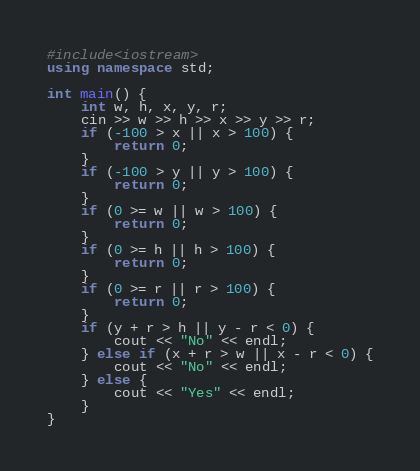Convert code to text. <code><loc_0><loc_0><loc_500><loc_500><_C++_>#include<iostream>
using namespace std;

int main() {
    int w, h, x, y, r;
    cin >> w >> h >> x >> y >> r;
    if (-100 > x || x > 100) {
        return 0;
    }
    if (-100 > y || y > 100) {
        return 0;
    }
    if (0 >= w || w > 100) {
        return 0;
    }
    if (0 >= h || h > 100) {
        return 0;
    }
    if (0 >= r || r > 100) {
        return 0;
    }
    if (y + r > h || y - r < 0) {
        cout << "No" << endl;
    } else if (x + r > w || x - r < 0) {
        cout << "No" << endl;
    } else {
        cout << "Yes" << endl;
    }
}</code> 